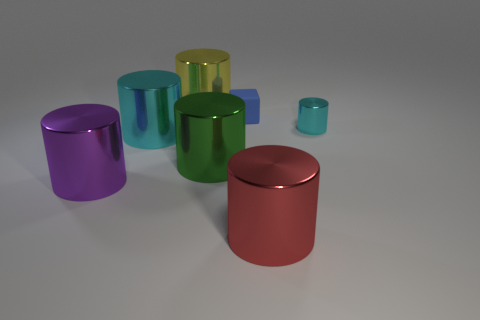Is there any other thing that is the same material as the tiny blue cube?
Your answer should be very brief. No. Is the shape of the large thing behind the small cube the same as  the large cyan thing?
Keep it short and to the point. Yes. The other cylinder that is the same color as the small metallic cylinder is what size?
Ensure brevity in your answer.  Large. How many red objects are cylinders or matte objects?
Ensure brevity in your answer.  1. How many other things are there of the same shape as the small metal thing?
Your answer should be compact. 5. The metallic object that is both to the right of the large green cylinder and behind the purple metal thing has what shape?
Give a very brief answer. Cylinder. There is a big green shiny cylinder; are there any big yellow objects on the left side of it?
Ensure brevity in your answer.  Yes. What size is the green metallic thing that is the same shape as the big cyan thing?
Provide a short and direct response. Large. Is the big red metal object the same shape as the tiny blue matte thing?
Ensure brevity in your answer.  No. There is a metal cylinder that is to the right of the thing that is in front of the purple cylinder; what is its size?
Keep it short and to the point. Small. 